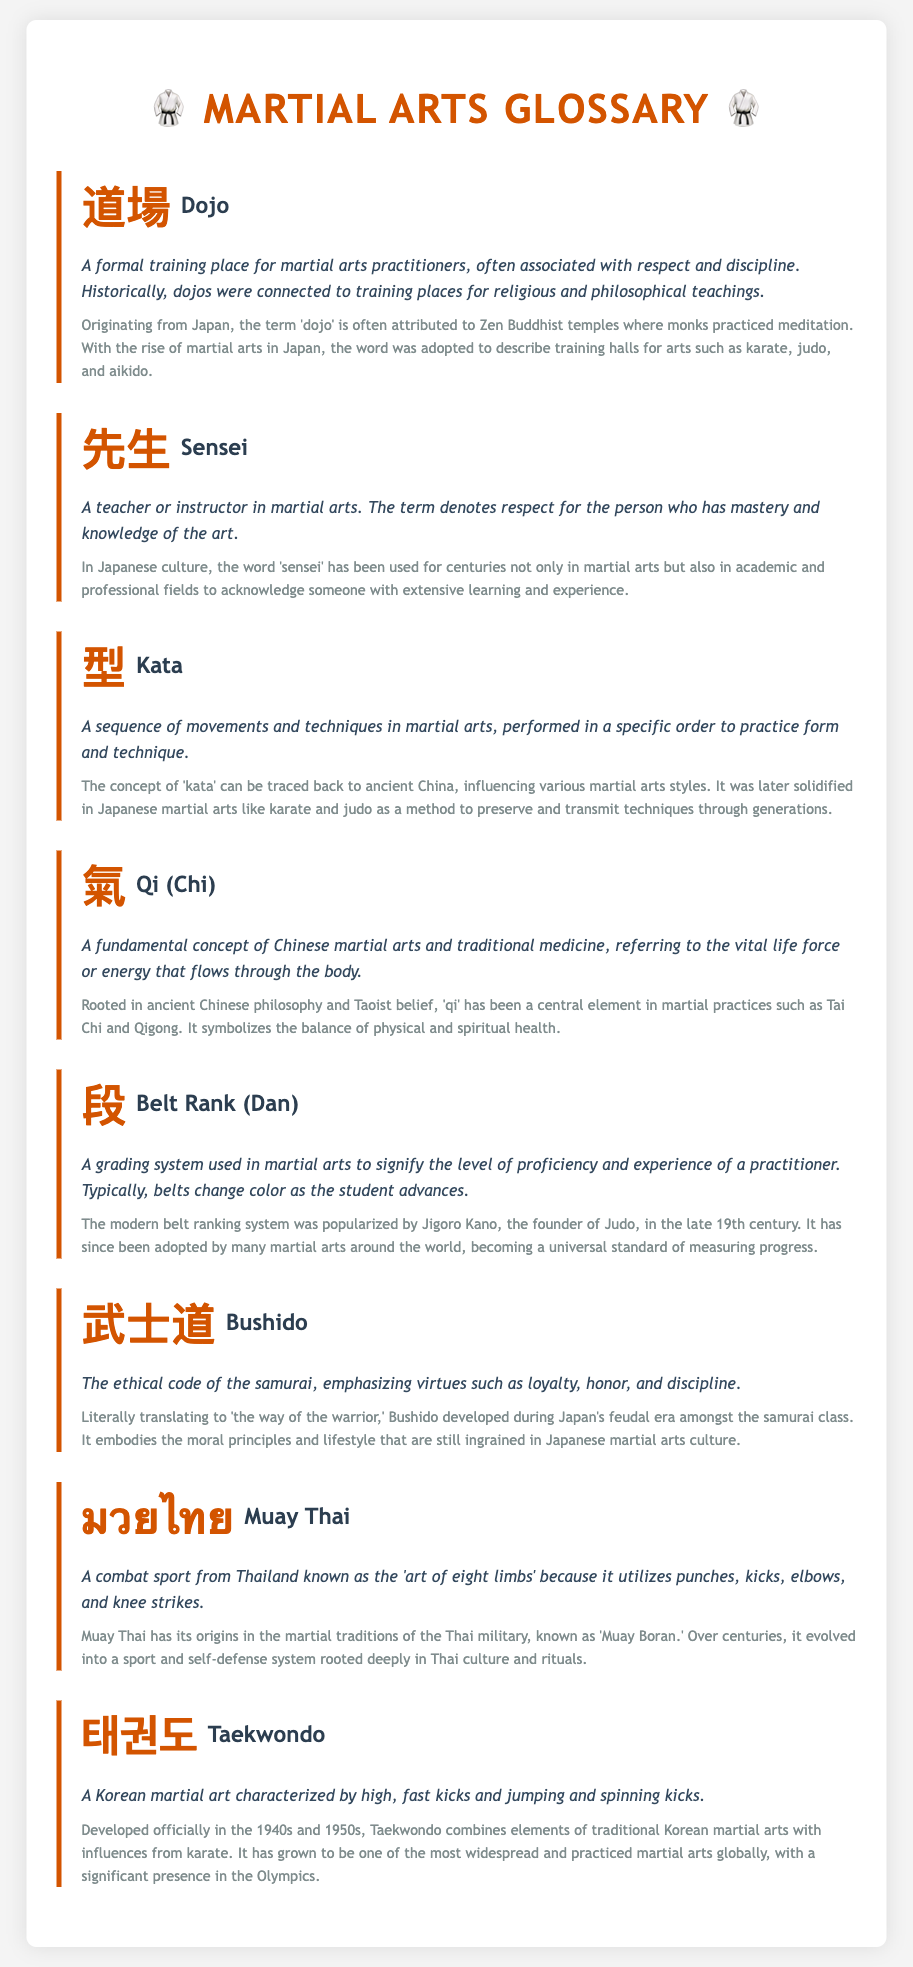what does "dojo" mean? The term 'dojo' refers to a formal training place for martial arts practitioners, associated with respect and discipline.
Answer: formal training place what is the symbol for "sensei"? The symbol for 'sensei' is 先生.
Answer: 先生 what is the historical origin of "kata"? The concept of 'kata' can be traced back to ancient China, influencing various martial arts styles.
Answer: ancient China what does "Qi" refer to? 'Qi' refers to the vital life force or energy that flows through the body.
Answer: vital life force who popularized the modern belt ranking system? The modern belt ranking system was popularized by Jigoro Kano.
Answer: Jigoro Kano what does "bushido" translate to? Bushido translates to 'the way of the warrior.'
Answer: the way of the warrior what is the primary characteristic of "Muay Thai"? Muay Thai is known as the 'art of eight limbs.'
Answer: art of eight limbs when was Taekwondo developed? Taekwondo was developed officially in the 1940s and 1950s.
Answer: 1940s and 1950s what is the relationship between "dojo" and Zen Buddhism? The word 'dojo' is associated with Zen Buddhist temples where monks practiced meditation.
Answer: Zen Buddhist temples 